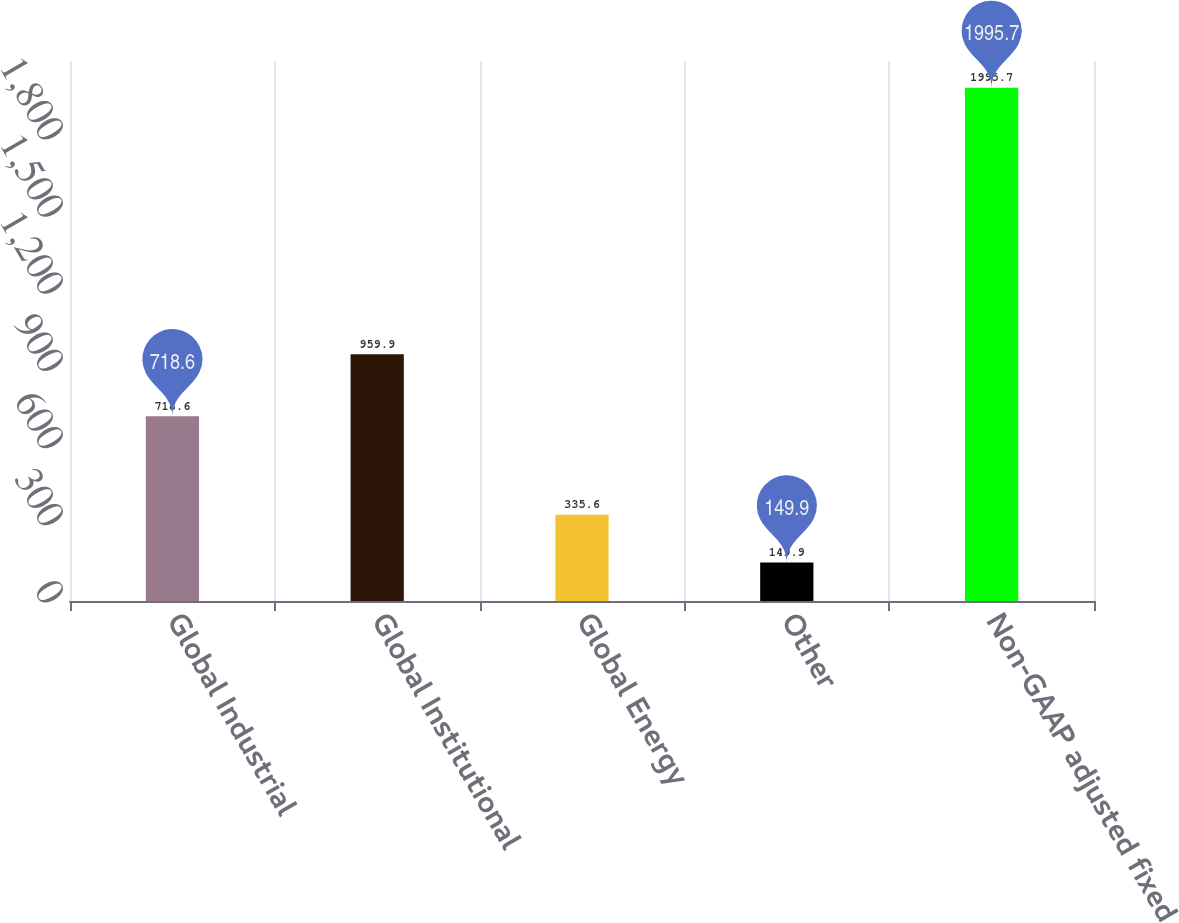Convert chart. <chart><loc_0><loc_0><loc_500><loc_500><bar_chart><fcel>Global Industrial<fcel>Global Institutional<fcel>Global Energy<fcel>Other<fcel>Non-GAAP adjusted fixed<nl><fcel>718.6<fcel>959.9<fcel>335.6<fcel>149.9<fcel>1995.7<nl></chart> 